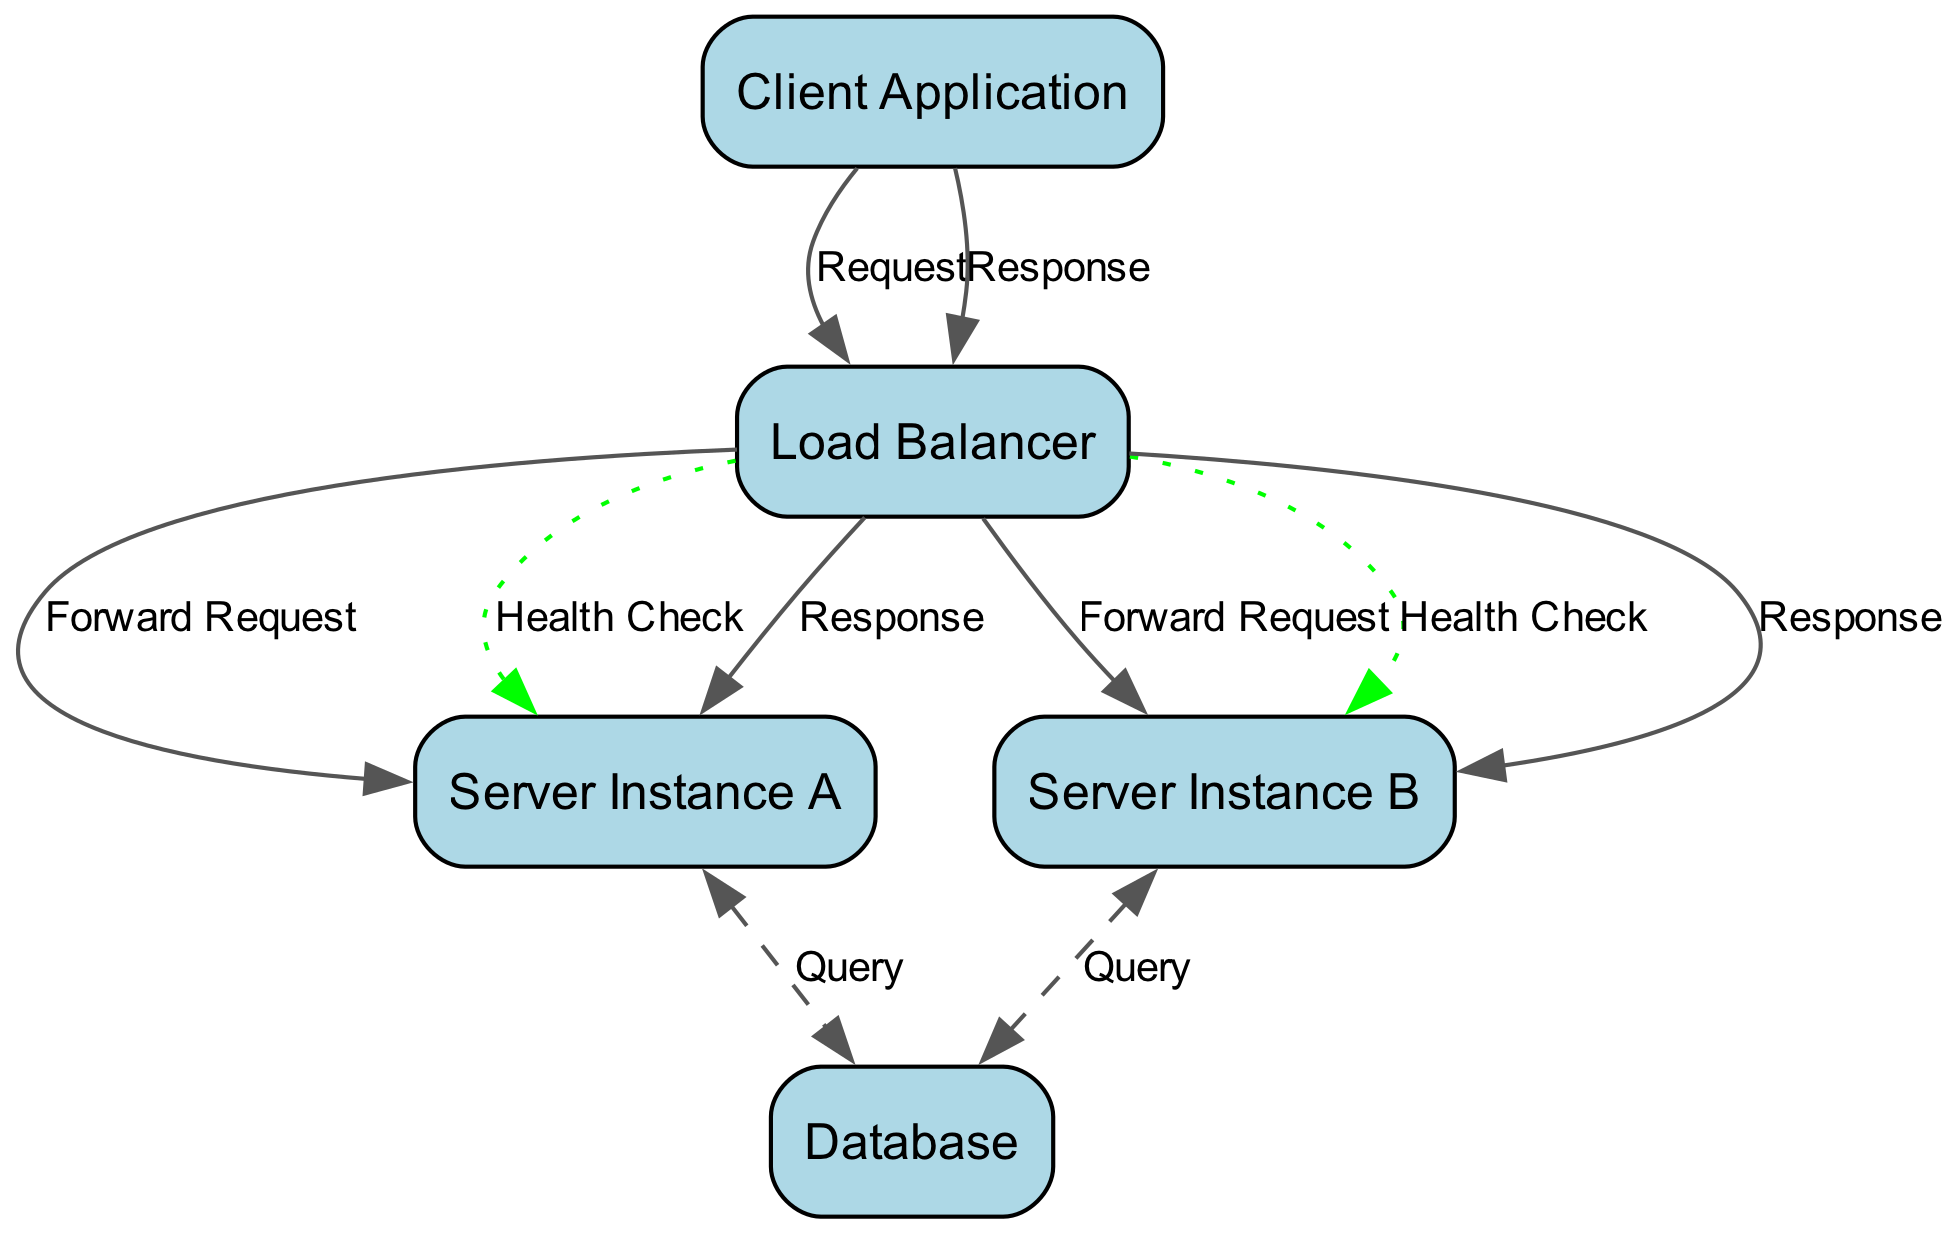What is the first component that the Client Application interacts with? The Client Application sends a request to the Load Balancer, which is the first component it communicates with in the diagram.
Answer: Load Balancer How many server instances are represented in the diagram? The diagram features two server instances, Server Instance A and Server Instance B. This can be counted directly from the elements presented.
Answer: 2 What message is sent from the Load Balancer to the Client Application? The final response sent back to the Client Application is labeled 'Response,' indicating the conclusion of the interaction from the Load Balancer back to the Client.
Answer: Response Which component is responsible for querying the Database? Both Server Instance A and Server Instance B are involved in sending queries to the Database as indicated by the edges labeled 'Query.'
Answer: Server Instance A and Server Instance B What type of health check is being performed on the Server Instances? The health check messages sent from the Load Balancer to Server Instance A and Server Instance B are labeled 'Health Check,' indicating they are performing a check on the server's status.
Answer: Health Check Which direction does the response travel after being processed by Server Instance A? The response travels back from Server Instance A to the Load Balancer, indicated by the edge labeled 'Response' directed towards the Load Balancer.
Answer: Back What style is used for the Query messages in the diagram? The Query messages between the Server Instances and the Database are styled as dashed lines, which visually differentiate them from other message types in the diagram.
Answer: Dashed What type of diagram is represented by the provided code and data? The code and data generate a sequence diagram that illustrates the interactions and flow of messages between components over time.
Answer: Sequence Diagram How does the Load Balancer distribute requests to server instances? The Load Balancer forwards requests to both Server Instance A and Server Instance B, indicating a method of load balancing by parallel request handling.
Answer: Forward Request 